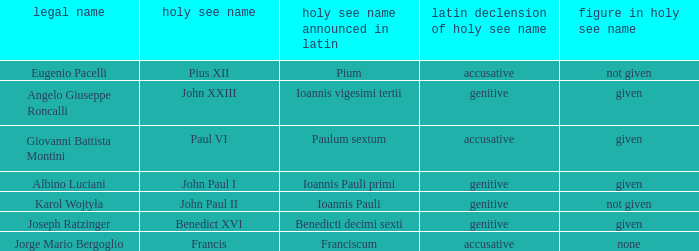For the pope born Eugenio Pacelli, what is the declension of his papal name? Accusative. 